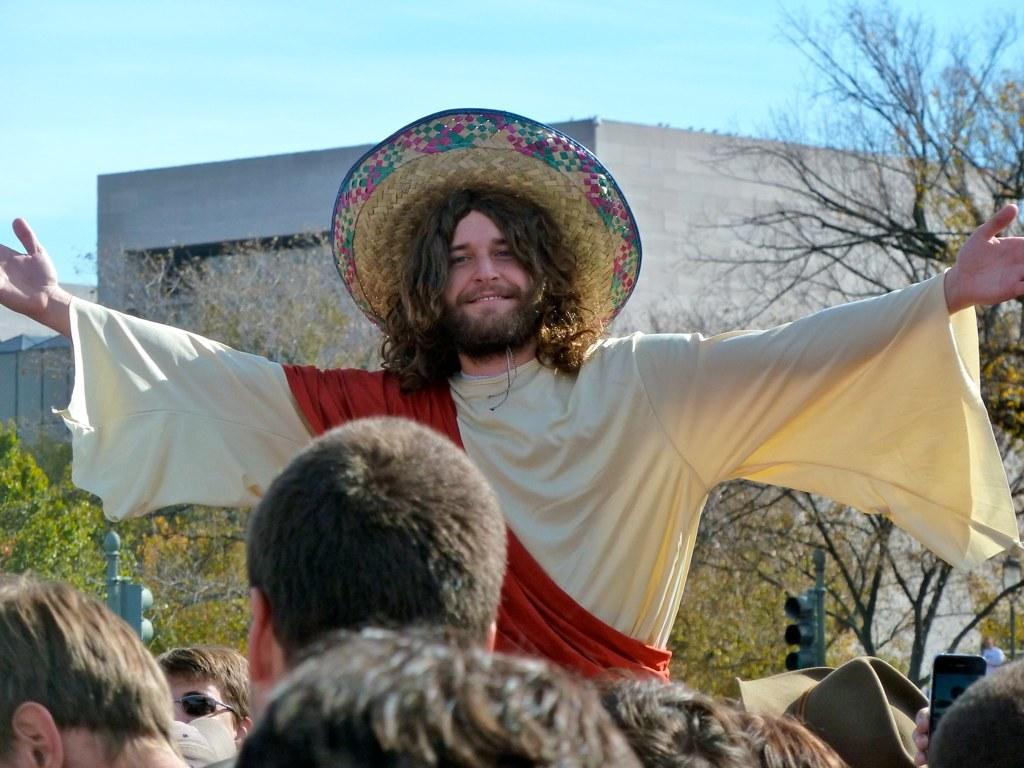Who or what is present in the image? There are people in the image. What type of natural elements can be seen in the image? There are trees in the image. What type of man-made structures are visible in the image? There are buildings in the image. What type of artificial light sources are present in the image? There are lights in the image. What type of vertical structures can be seen in the image? There are poles in the image. What is visible in the background of the image? The sky is visible in the background of the image. How many hands are visible in the image? There is no mention of hands in the provided facts, so it cannot be determined how many hands are visible in the image. 